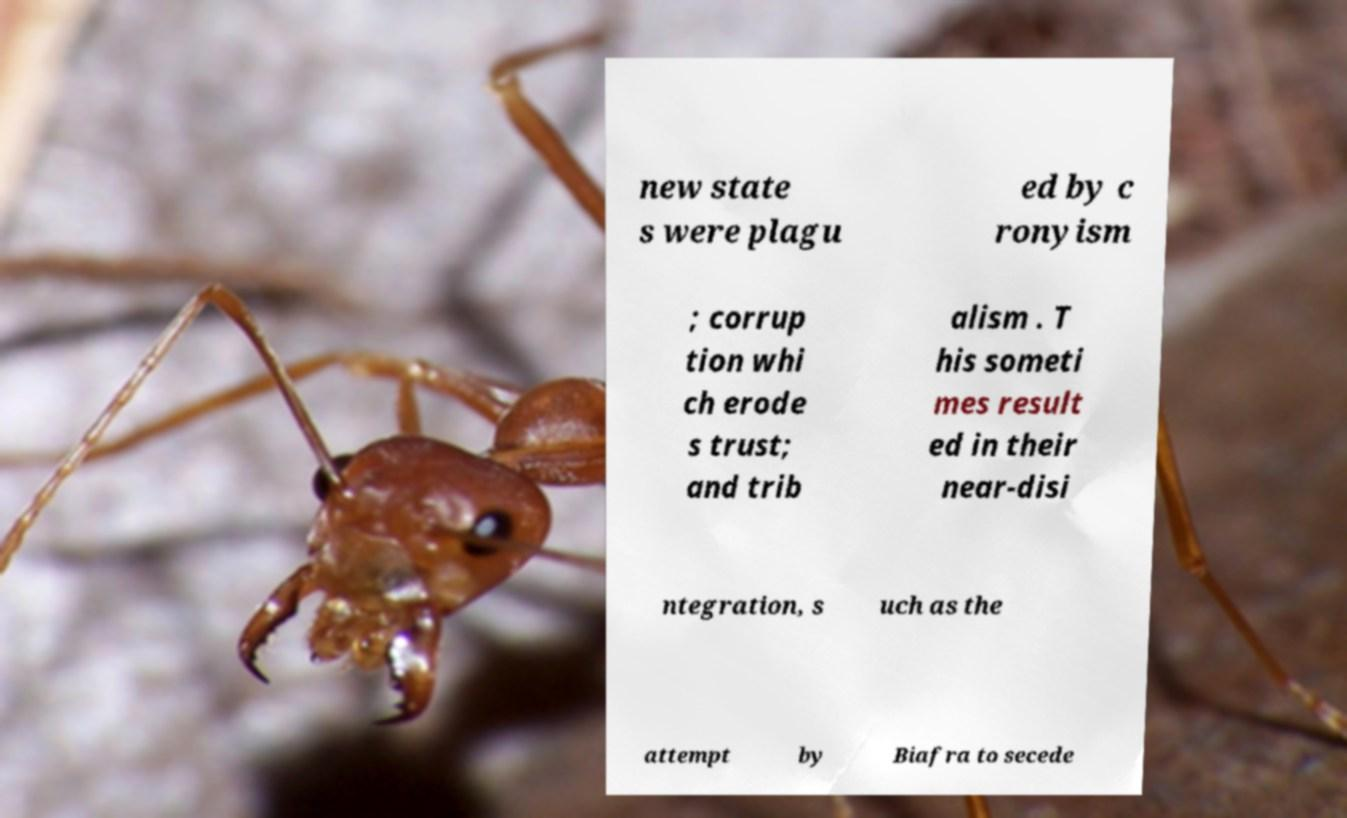What messages or text are displayed in this image? I need them in a readable, typed format. new state s were plagu ed by c ronyism ; corrup tion whi ch erode s trust; and trib alism . T his someti mes result ed in their near-disi ntegration, s uch as the attempt by Biafra to secede 